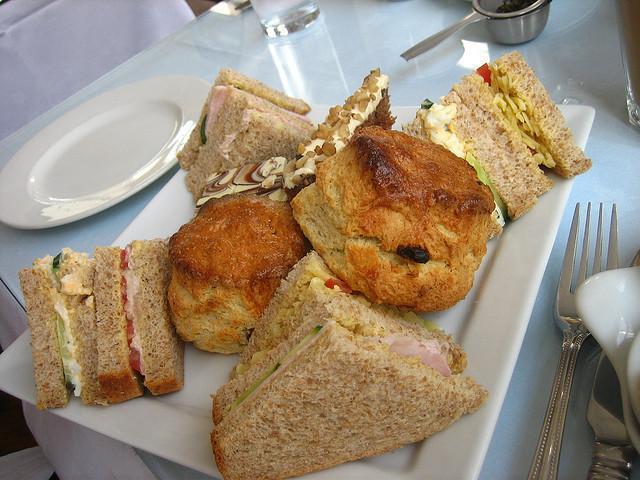What time is conducive to take the meal above?
Choose the right answer from the provided options to respond to the question.
Options: Morning, supper, none, lunch. Morning. 